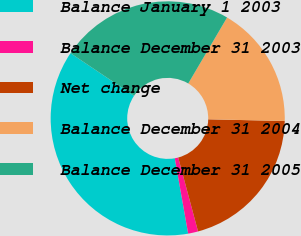Convert chart to OTSL. <chart><loc_0><loc_0><loc_500><loc_500><pie_chart><fcel>Balance January 1 2003<fcel>Balance December 31 2003<fcel>Net change<fcel>Balance December 31 2004<fcel>Balance December 31 2005<nl><fcel>37.2%<fcel>1.38%<fcel>20.47%<fcel>16.89%<fcel>24.06%<nl></chart> 